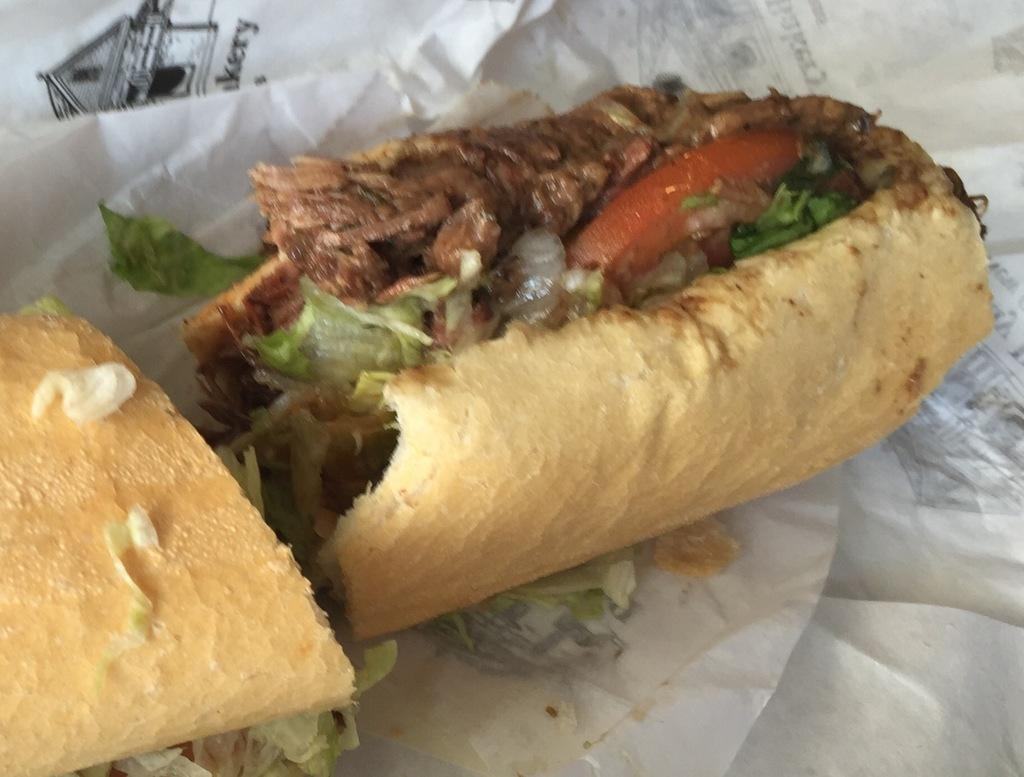What type of food is present in the image? There is a hot dog in the image. What else can be seen at the bottom of the image? There are papers at the bottom of the image. What is the chance of the hot dog being submerged in water in the image? There is no water present in the image, so it is not possible to determine the chance of the hot dog being submerged in water. 